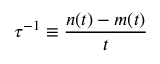<formula> <loc_0><loc_0><loc_500><loc_500>\tau ^ { - 1 } \equiv \frac { n ( t ) - m ( t ) } { t }</formula> 